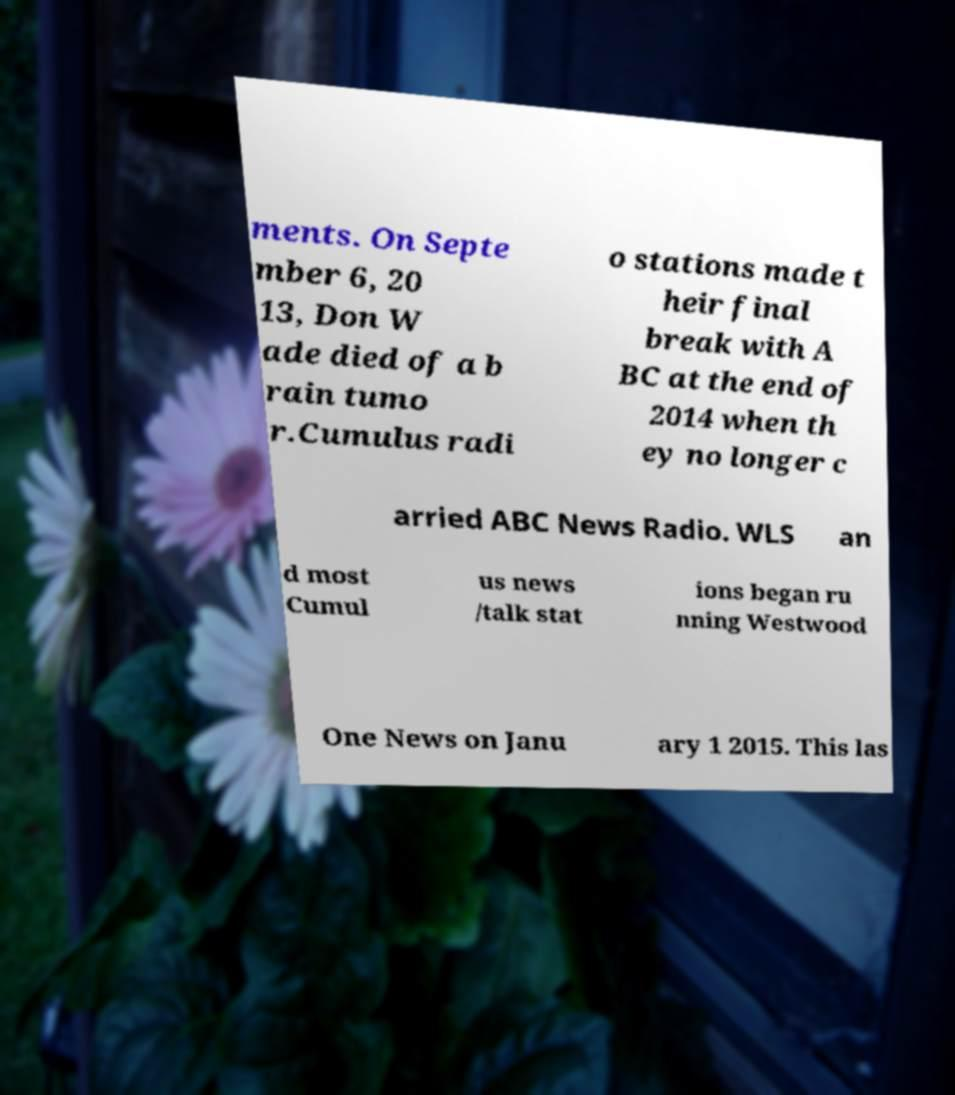Please identify and transcribe the text found in this image. ments. On Septe mber 6, 20 13, Don W ade died of a b rain tumo r.Cumulus radi o stations made t heir final break with A BC at the end of 2014 when th ey no longer c arried ABC News Radio. WLS an d most Cumul us news /talk stat ions began ru nning Westwood One News on Janu ary 1 2015. This las 